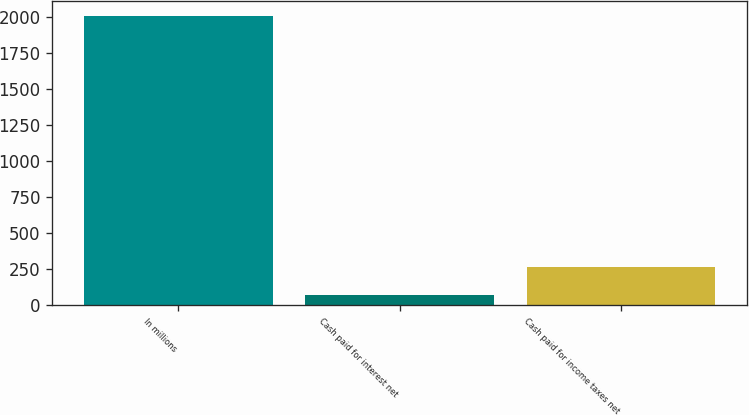Convert chart. <chart><loc_0><loc_0><loc_500><loc_500><bar_chart><fcel>In millions<fcel>Cash paid for interest net<fcel>Cash paid for income taxes net<nl><fcel>2013<fcel>69.4<fcel>263.76<nl></chart> 